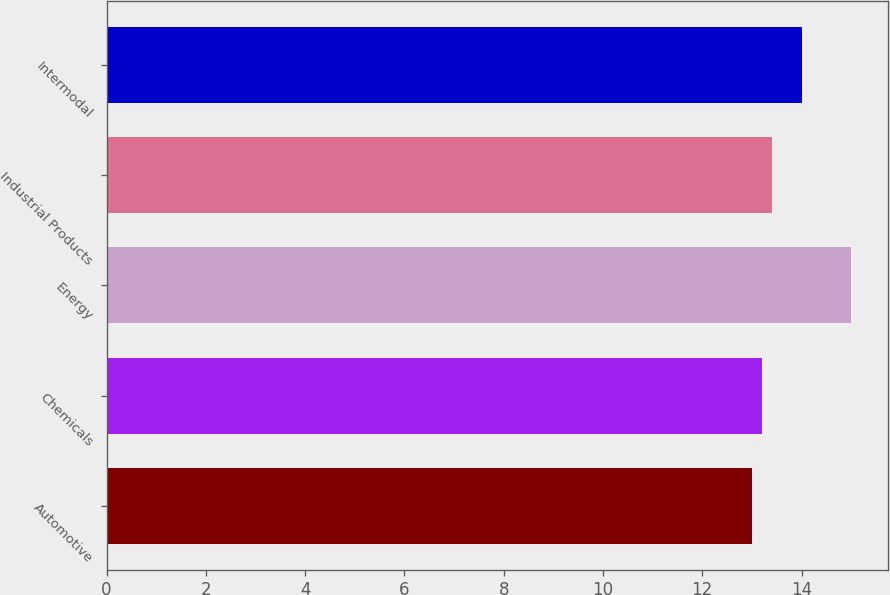Convert chart to OTSL. <chart><loc_0><loc_0><loc_500><loc_500><bar_chart><fcel>Automotive<fcel>Chemicals<fcel>Energy<fcel>Industrial Products<fcel>Intermodal<nl><fcel>13<fcel>13.2<fcel>15<fcel>13.4<fcel>14<nl></chart> 